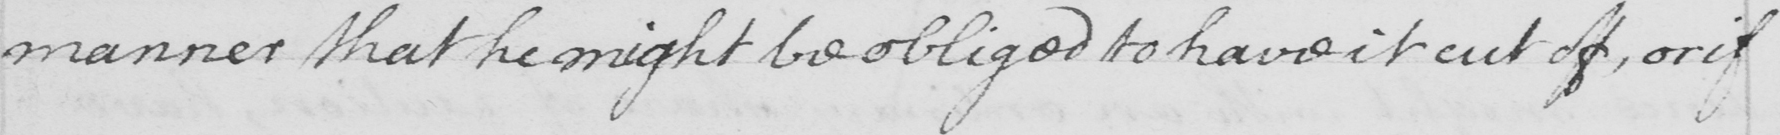Please provide the text content of this handwritten line. manner that he might be obliged to have it cut off, or if 